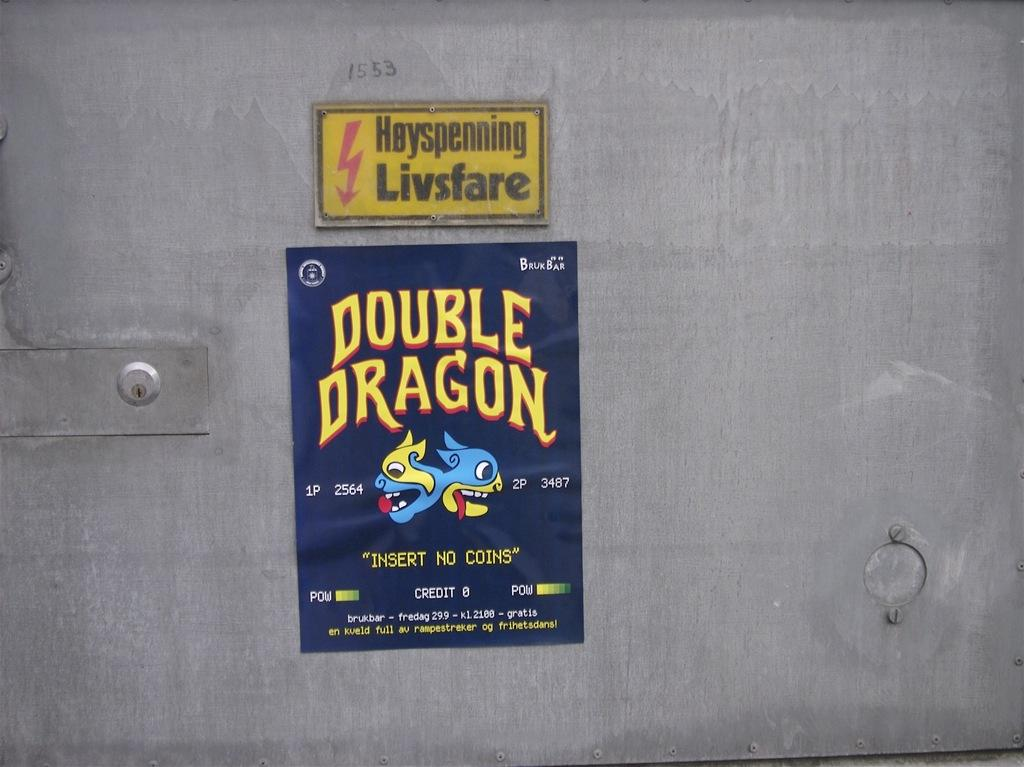Provide a one-sentence caption for the provided image. double dragon sticker is stuck onto the wall. 